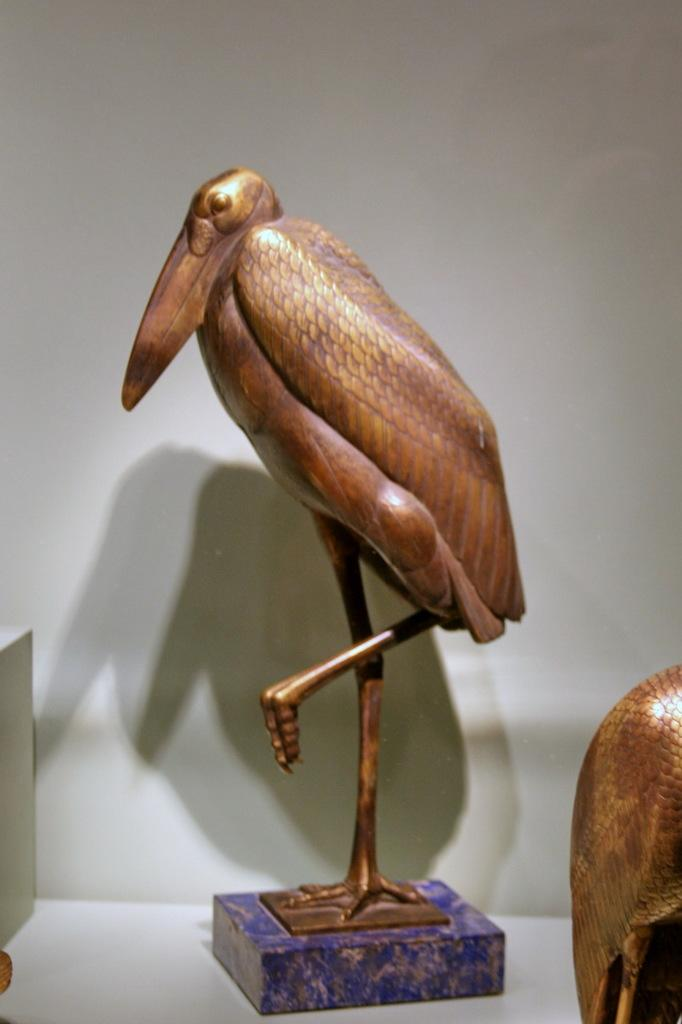What objects are present in the image? There are statues in the image. What color is the background of the image? The background of the image is white. Is there a boat in the image? No, there is no boat present in the image. What is the wealth of the statues in the image? The statues in the image do not have wealth, as they are inanimate objects. 